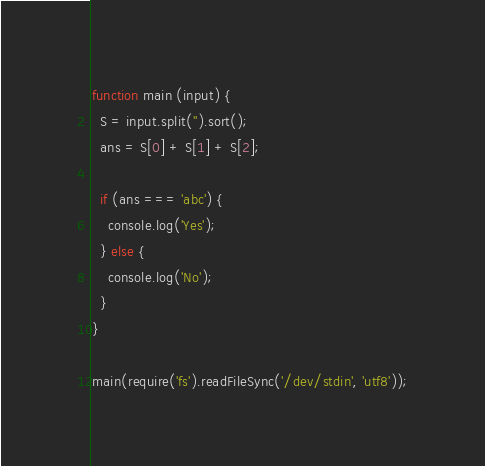<code> <loc_0><loc_0><loc_500><loc_500><_JavaScript_>function main (input) {
  S = input.split('').sort();
  ans = S[0] + S[1] + S[2];

  if (ans === 'abc') {
    console.log('Yes');
  } else {
    console.log('No');
  }
}

main(require('fs').readFileSync('/dev/stdin', 'utf8'));</code> 